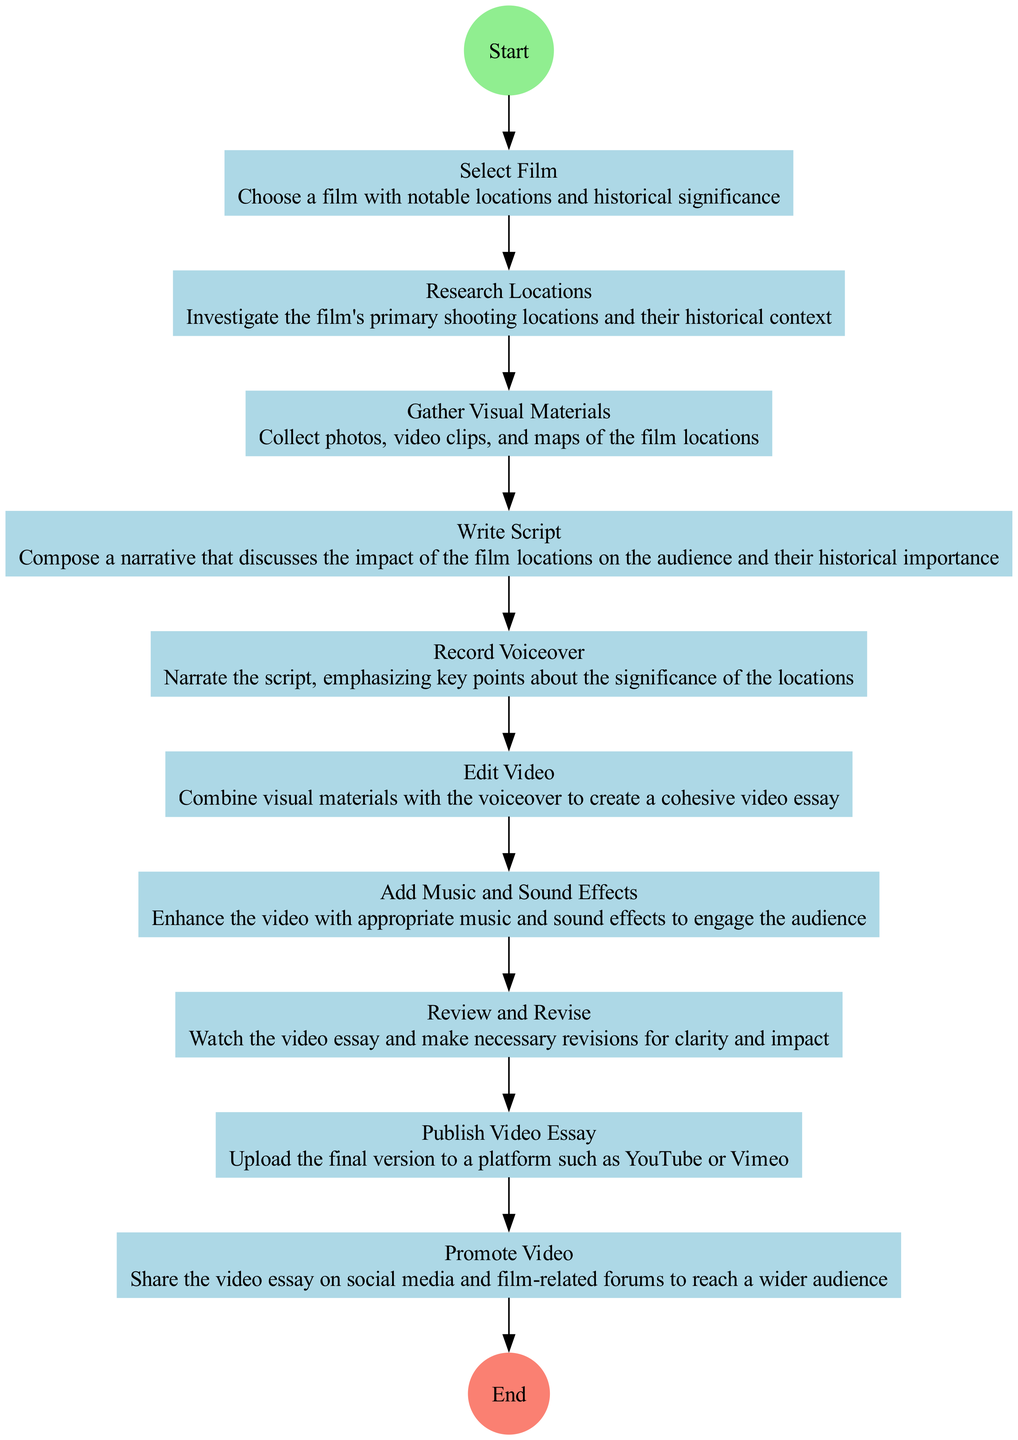What is the first step in the activity diagram? The first step, as indicated in the diagram, is "Select Film," which pertains to the action of choosing a film with notable locations and historical significance.
Answer: Select Film How many steps are involved in the process? The diagram includes ten steps, starting from "Select Film" and ending with "Promote Video." Each step represents a distinct action required to create the video essay.
Answer: 10 What is the last action taken in the process before ending? The last action in the activity diagram is "Publish Video Essay," which signifies uploading the final version of the video essay to a platform like YouTube or Vimeo before concluding the process.
Answer: Publish Video Essay Which action immediately follows "Gather Visual Materials"? The action that immediately follows "Gather Visual Materials" is "Write Script." This shows the sequence in which the steps flow from gathering resources to creating a narrative for the video essay.
Answer: Write Script What type of node represents the "Review and Revise" action? The "Review and Revise" action is represented by a rectangle, indicating that it is a standard process step in the workflow of creating the video essay.
Answer: Rectangle What connects "Edit Video" to "Add Music and Sound Effects"? The connection between "Edit Video" and "Add Music and Sound Effects" is represented by a directed edge or arrow, which indicates the progression from one action to the next in the process of video production.
Answer: Directed edge What general outcome does the diagram illustrate? The general outcome illustrated by the diagram is the creation and promotion of a video essay that showcases film locations and their historical significance.
Answer: Video essay creation Is there a step related to enhancing the video? Yes, the step "Add Music and Sound Effects" specifically pertains to enhancing the video, which is vital for engaging the audience and improving the overall experience of the video essay.
Answer: Add Music and Sound Effects What is the purpose of "Promote Video" in the process? The purpose of "Promote Video" is to share the finished video essay on social media and film-related forums, enabling it to reach a wider audience and increase its visibility.
Answer: Share the video essay 